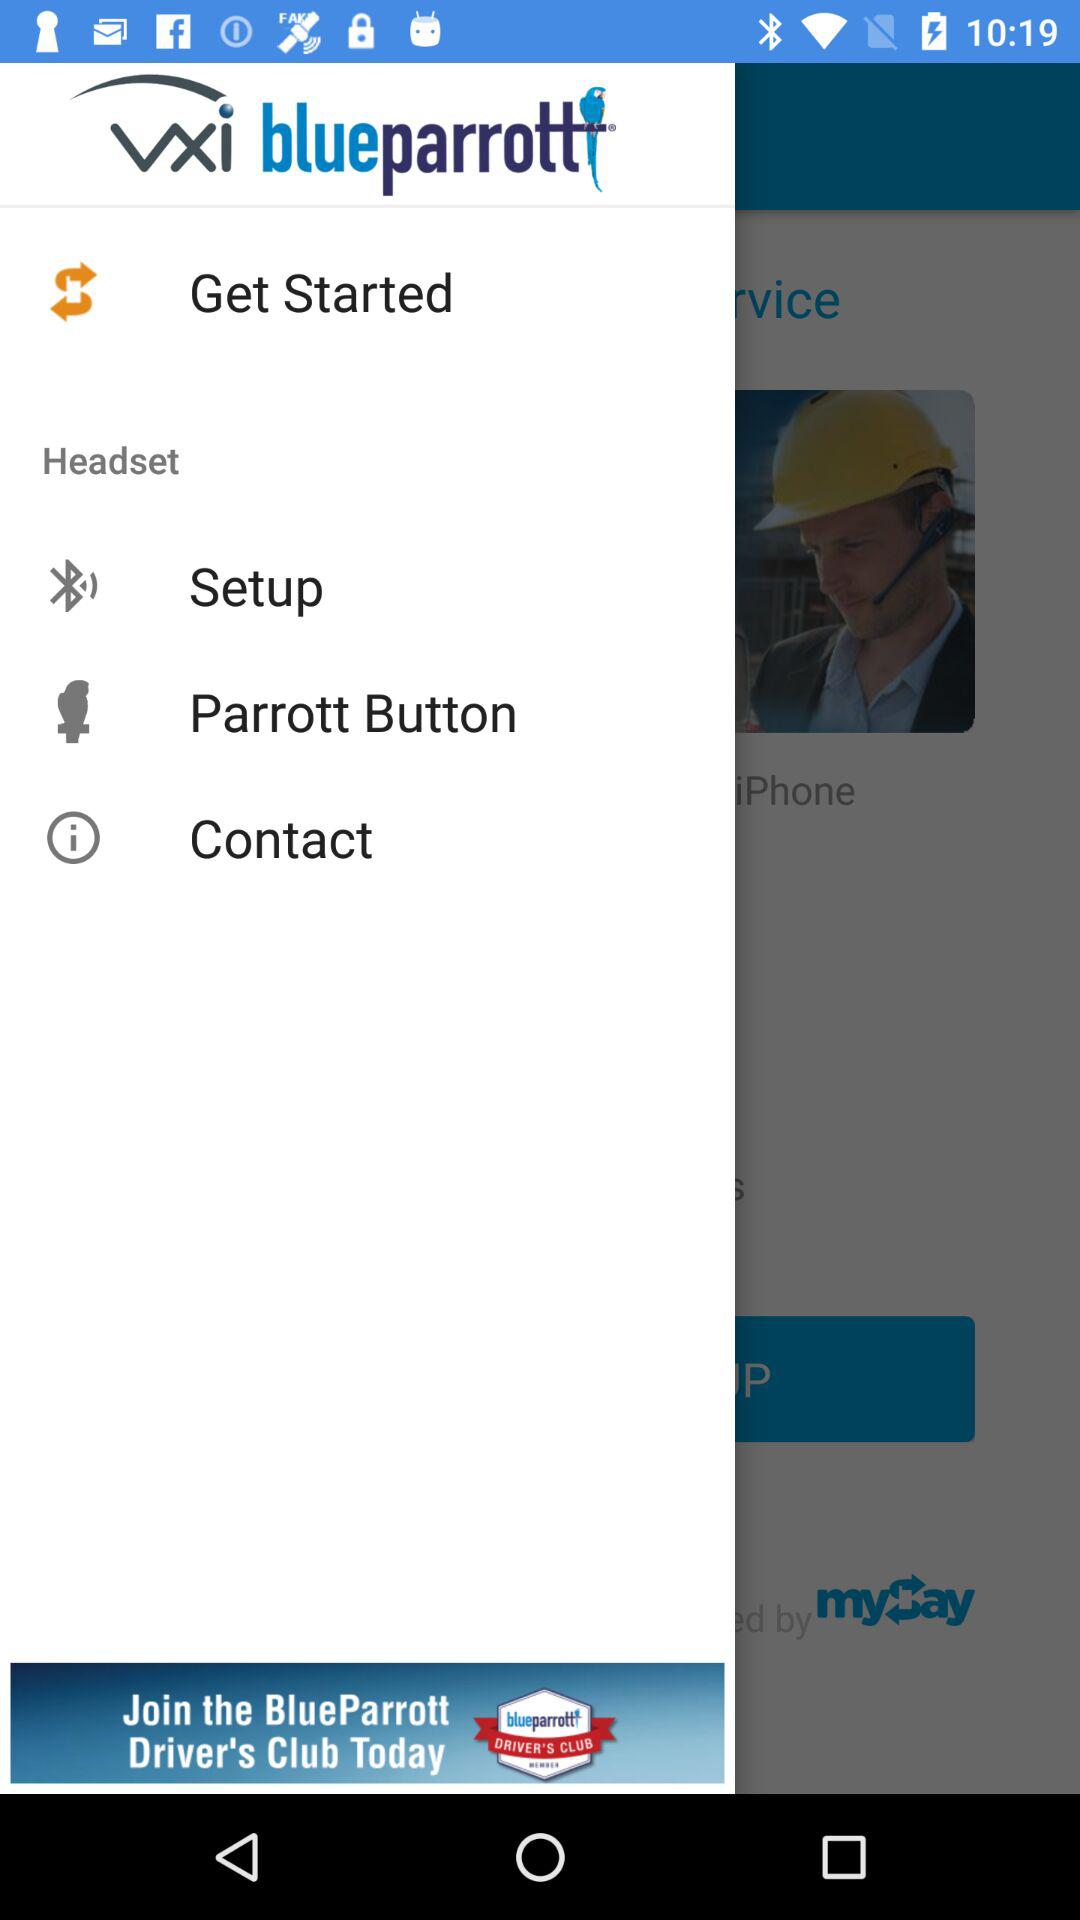What is the application Name? The application name is "vxi blueparrott". 